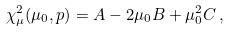<formula> <loc_0><loc_0><loc_500><loc_500>\chi _ { \mu } ^ { 2 } ( \mu _ { 0 } , p ) = A - 2 \mu _ { 0 } B + \mu _ { 0 } ^ { 2 } C \, ,</formula> 